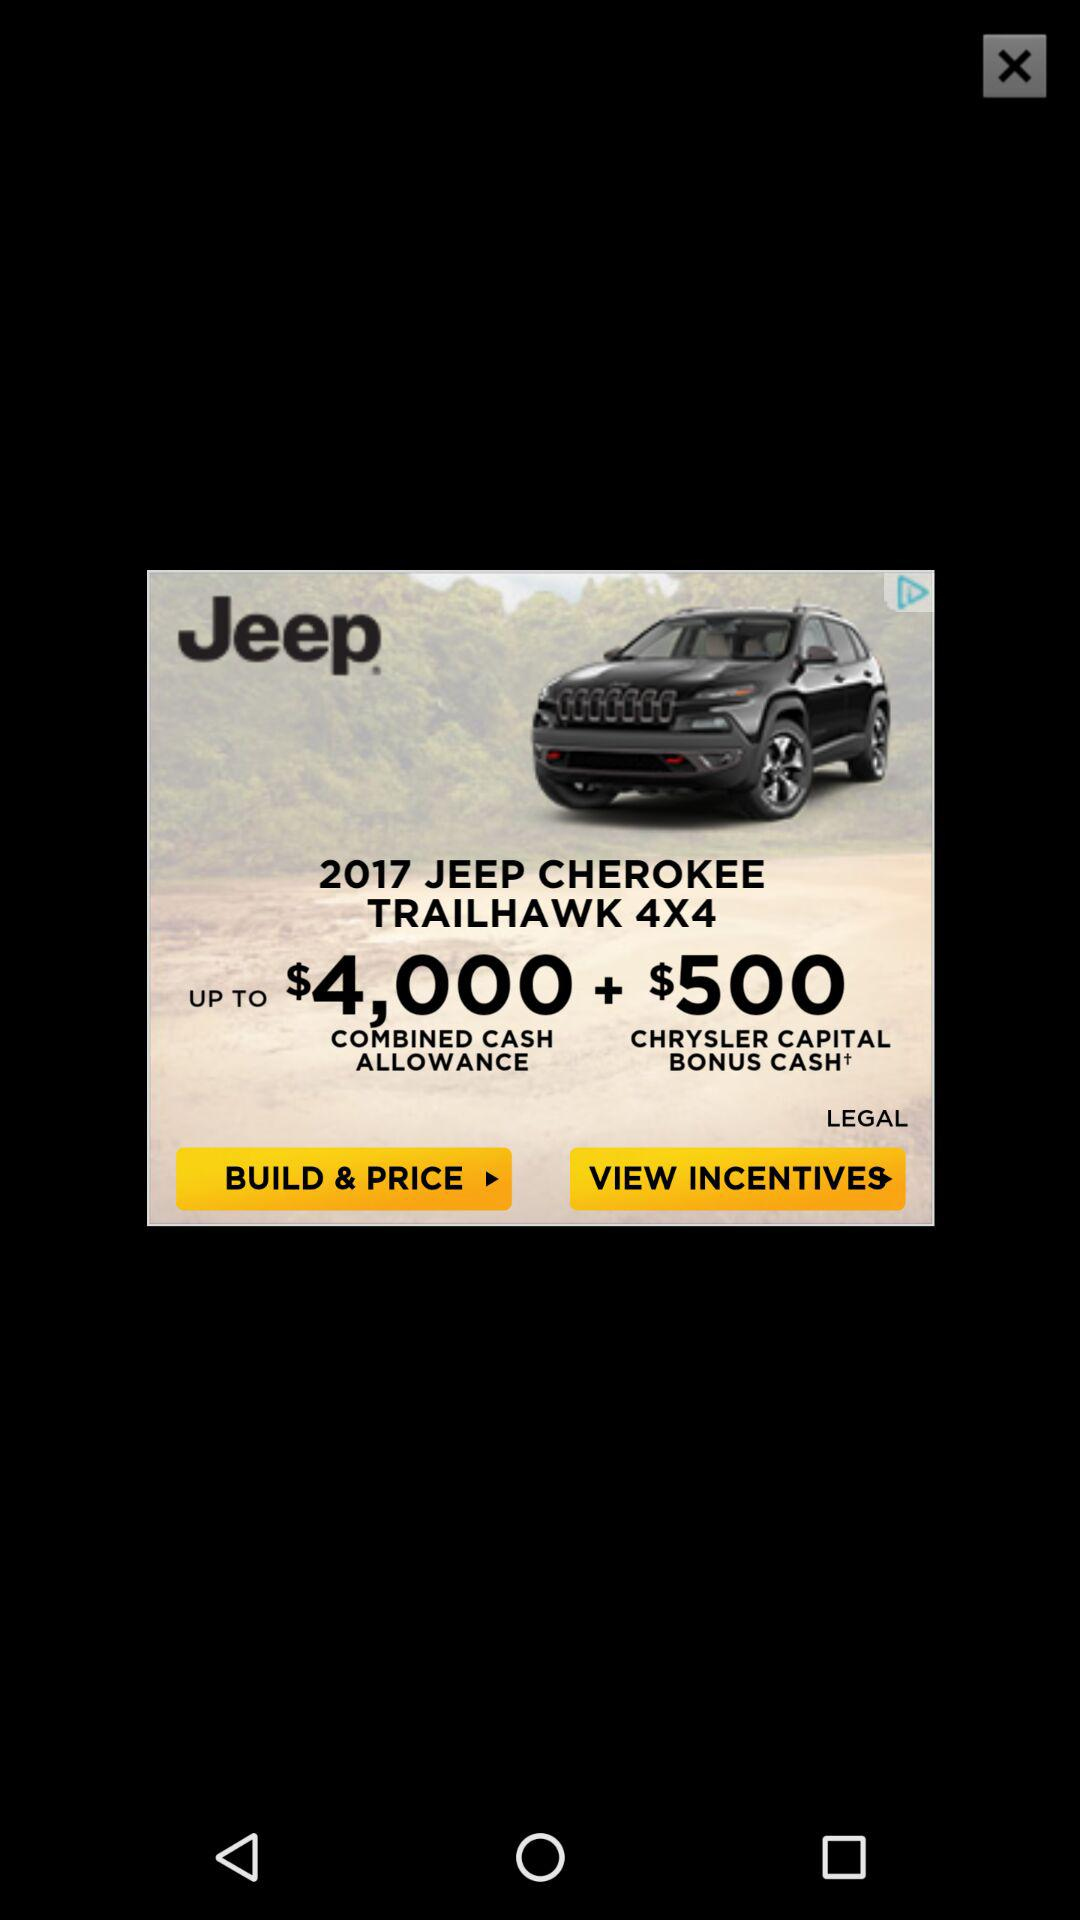How much is the combined cash allowance?
Answer the question using a single word or phrase. $4,500 